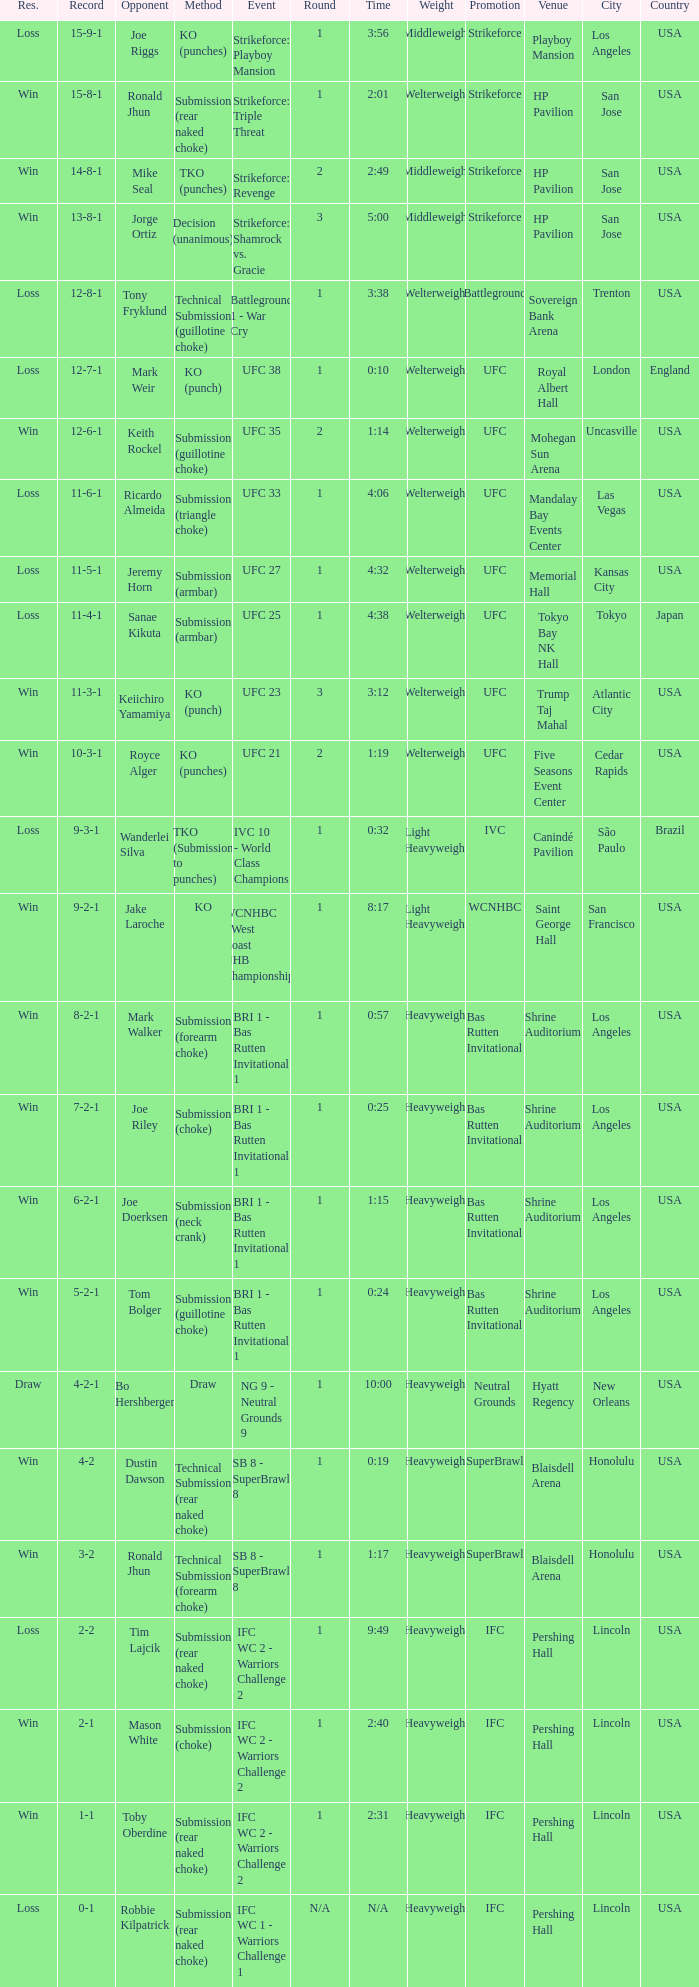What was the record when the method of resolution was KO? 9-2-1. 